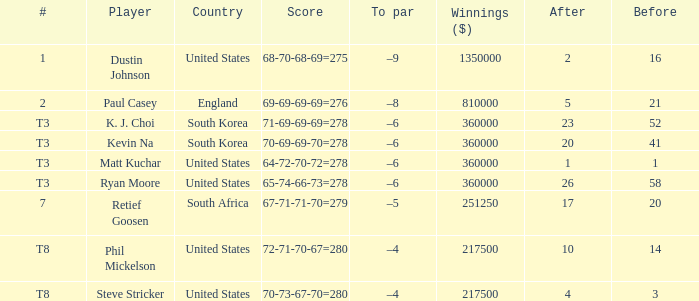When phil mickelson is the player, how many times is a "to par" listed? 1.0. 